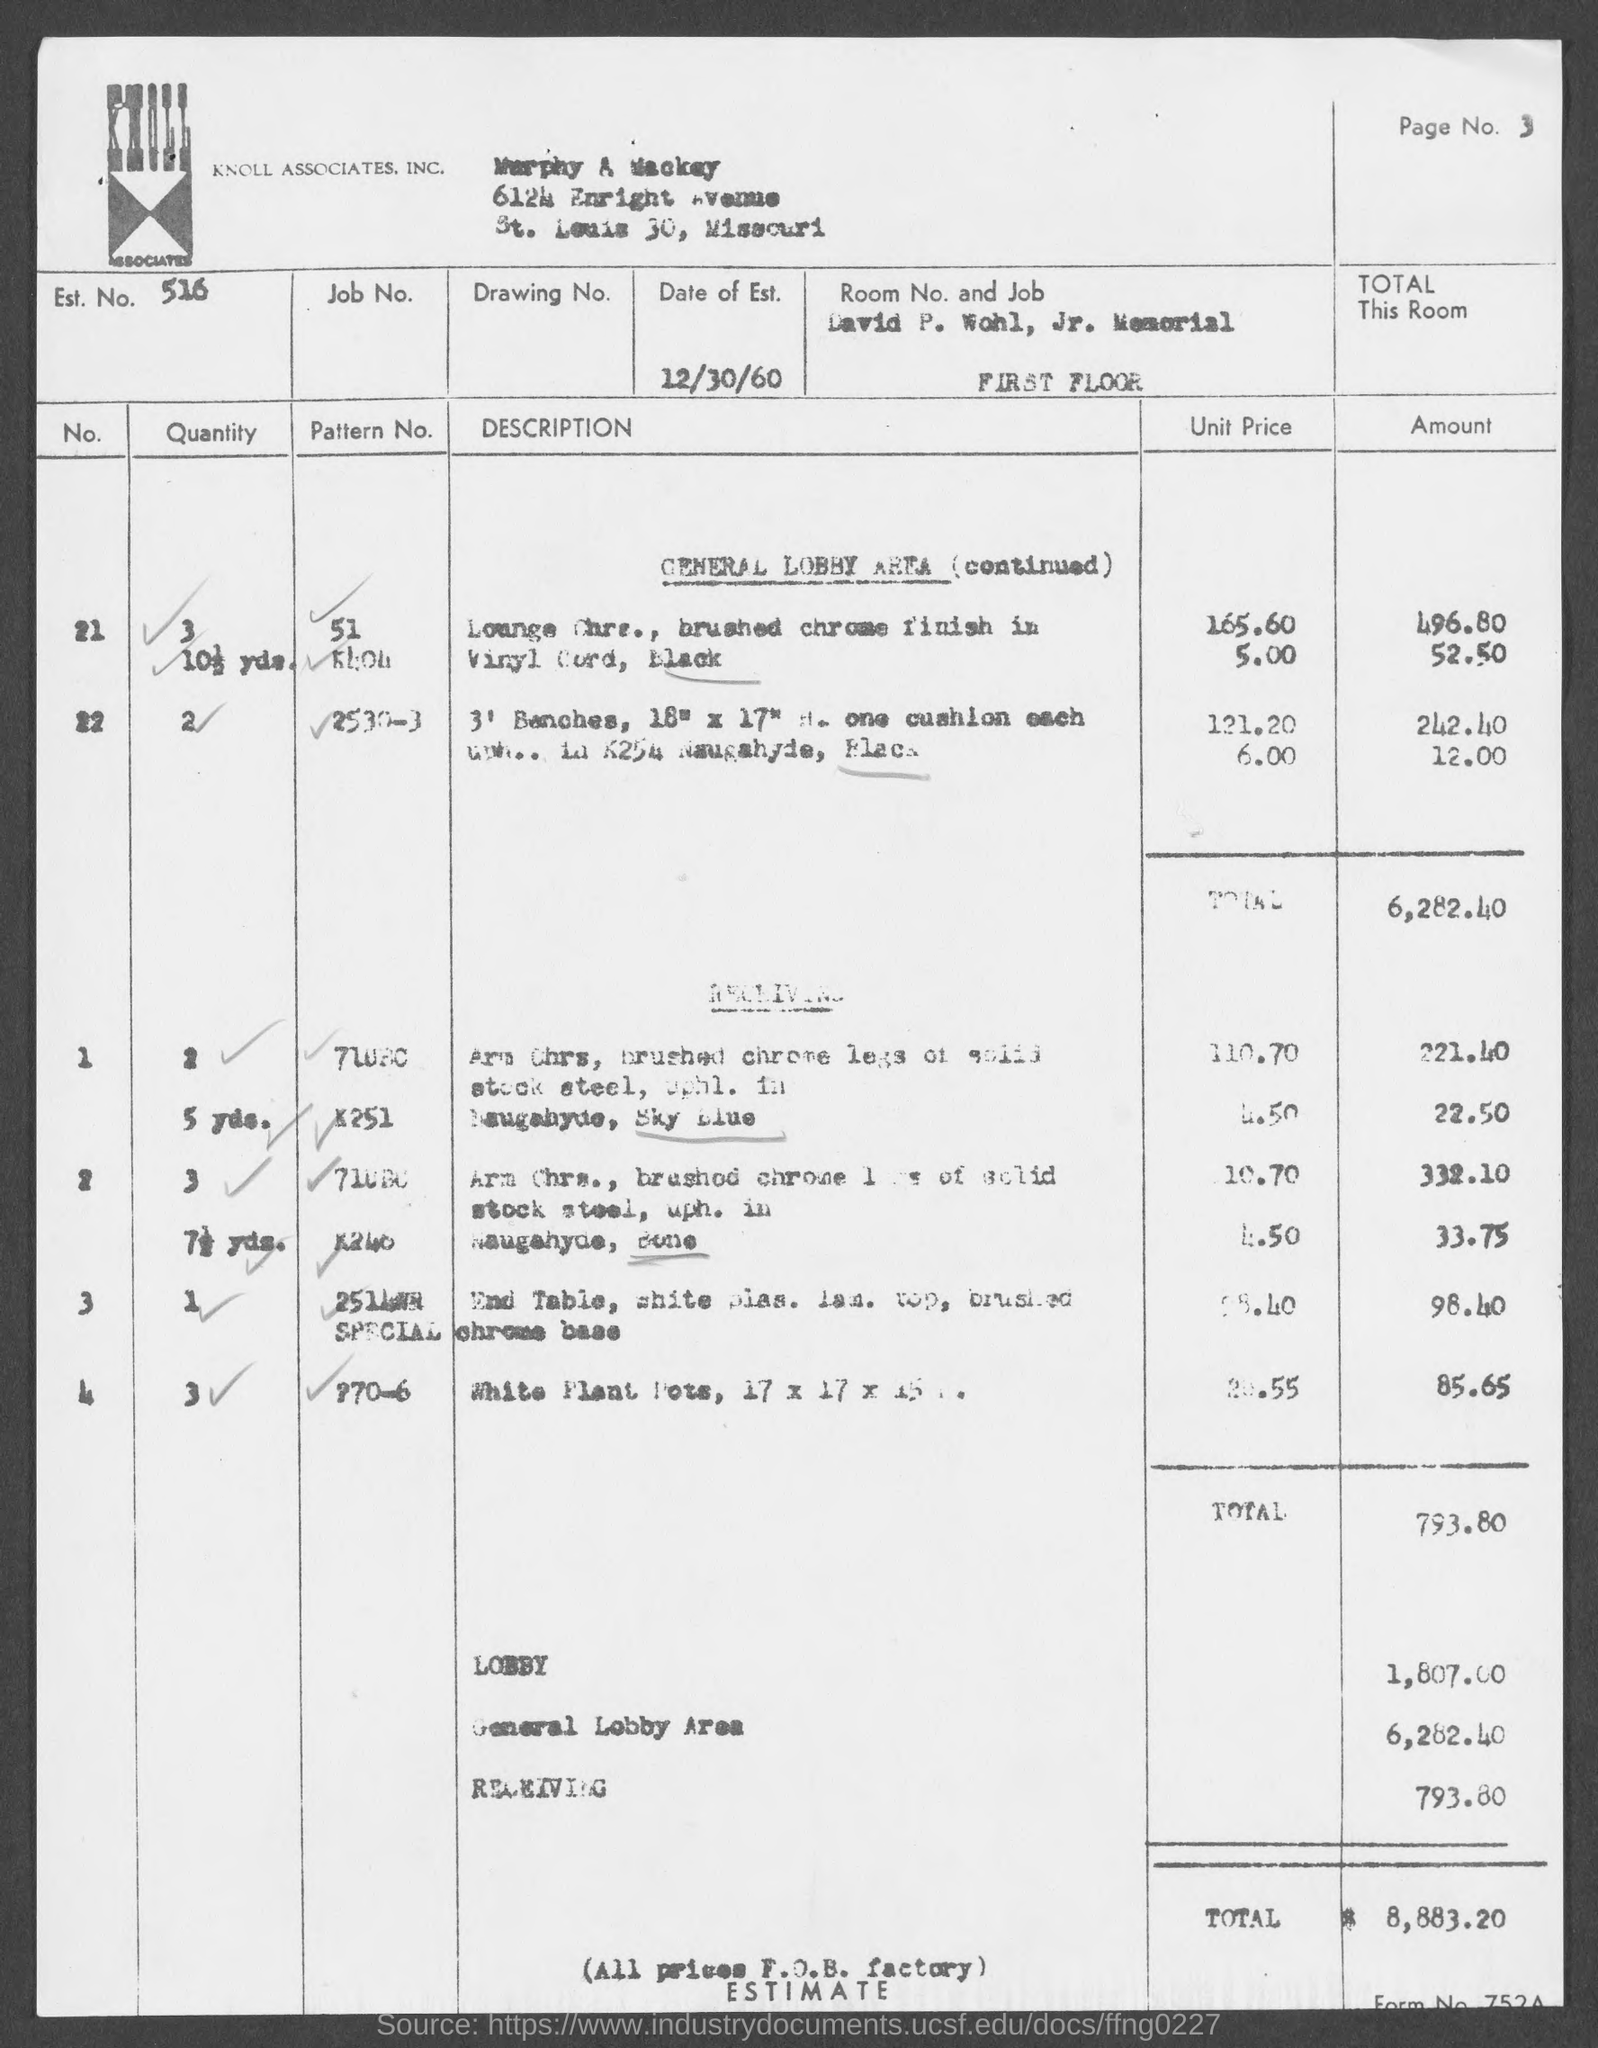Which company is mentioned in the header of the document?
Ensure brevity in your answer.  KNOLL ASSOCIATES, INC. What is the Est. No. given in the document?
Your response must be concise. 516. What is the Date of Est. given in the document?
Keep it short and to the point. 12/30/60. What is the estimated amount for General Lobby area mentioned in the document?
Make the answer very short. 6,282.40. What is the estimated amount for RECEIVING area given in the document?
Your answer should be very brief. 793.80. What is the estimated amount for LOBBY as given in the document?
Offer a very short reply. 1,807.00. 